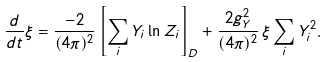Convert formula to latex. <formula><loc_0><loc_0><loc_500><loc_500>\frac { d } { d t } \xi = \frac { - 2 } { ( 4 \pi ) ^ { 2 } } \left [ \sum _ { i } Y _ { i } \ln Z _ { i } \right ] _ { D } + \frac { 2 g _ { Y } ^ { 2 } } { ( 4 \pi ) ^ { 2 } } \, \xi \sum _ { i } Y _ { i } ^ { 2 } .</formula> 